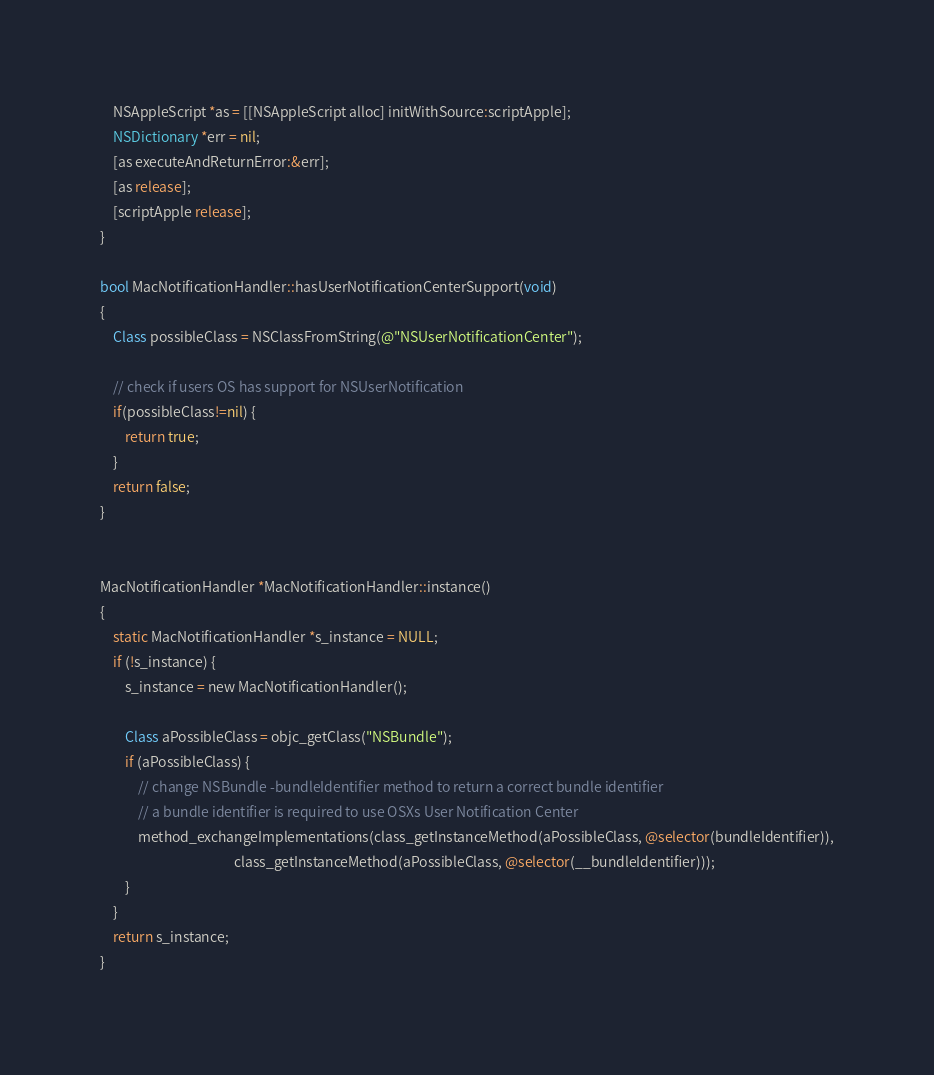Convert code to text. <code><loc_0><loc_0><loc_500><loc_500><_ObjectiveC_>
    NSAppleScript *as = [[NSAppleScript alloc] initWithSource:scriptApple];
    NSDictionary *err = nil;
    [as executeAndReturnError:&err];
    [as release];
    [scriptApple release];
}

bool MacNotificationHandler::hasUserNotificationCenterSupport(void)
{
    Class possibleClass = NSClassFromString(@"NSUserNotificationCenter");

    // check if users OS has support for NSUserNotification
    if(possibleClass!=nil) {
        return true;
    }
    return false;
}


MacNotificationHandler *MacNotificationHandler::instance()
{
    static MacNotificationHandler *s_instance = NULL;
    if (!s_instance) {
        s_instance = new MacNotificationHandler();
        
        Class aPossibleClass = objc_getClass("NSBundle");
        if (aPossibleClass) {
            // change NSBundle -bundleIdentifier method to return a correct bundle identifier
            // a bundle identifier is required to use OSXs User Notification Center
            method_exchangeImplementations(class_getInstanceMethod(aPossibleClass, @selector(bundleIdentifier)),
                                           class_getInstanceMethod(aPossibleClass, @selector(__bundleIdentifier)));
        }
    }
    return s_instance;
}
</code> 